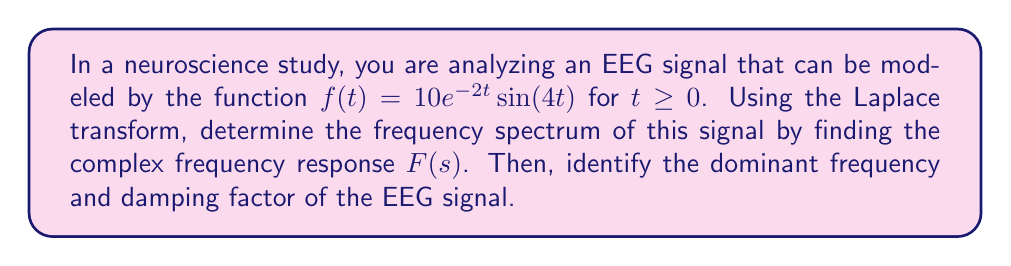Help me with this question. To solve this problem, we'll follow these steps:

1) First, recall the Laplace transform of $e^{at}\sin(bt)$:

   $\mathcal{L}\{e^{at}\sin(bt)\} = \frac{b}{(s-a)^2 + b^2}$

2) In our case, $a = -2$ and $b = 4$. We also have a coefficient of 10. So, we can write:

   $F(s) = \mathcal{L}\{10e^{-2t}\sin(4t)\} = 10 \cdot \frac{4}{(s+2)^2 + 4^2}$

3) Simplify:

   $F(s) = \frac{40}{(s+2)^2 + 16}$

4) This is our complex frequency response. To find the dominant frequency, we need to look at the imaginary part of the poles of $F(s)$.

5) The poles are the values of $s$ that make the denominator zero:

   $(s+2)^2 + 16 = 0$
   $s+2 = \pm 4i$
   $s = -2 \pm 4i$

6) The imaginary part of the poles gives us the angular frequency: $\omega = 4$ rad/s

7) To convert to Hz, we divide by $2\pi$:

   $f = \frac{4}{2\pi} \approx 0.64$ Hz

8) The real part of the poles gives us the damping factor: $\alpha = 2$
Answer: The complex frequency response is $F(s) = \frac{40}{(s+2)^2 + 16}$. The dominant frequency of the EEG signal is approximately 0.64 Hz, and the damping factor is 2. 